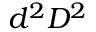<formula> <loc_0><loc_0><loc_500><loc_500>d ^ { 2 } D ^ { 2 }</formula> 